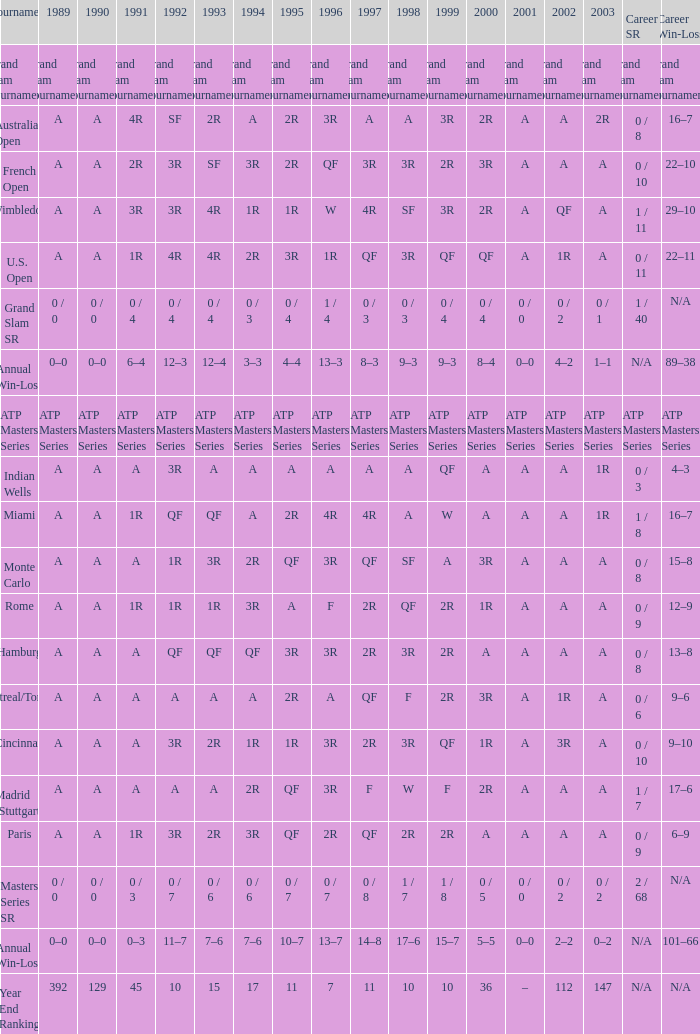If the values for 1989, 1995, and 1996 are a, qf, and 3r, respectively QF. 